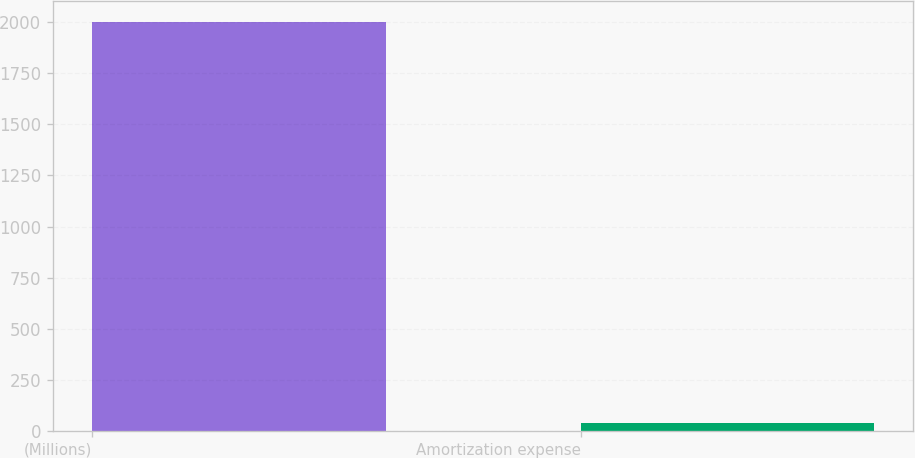<chart> <loc_0><loc_0><loc_500><loc_500><bar_chart><fcel>(Millions)<fcel>Amortization expense<nl><fcel>2002<fcel>39<nl></chart> 